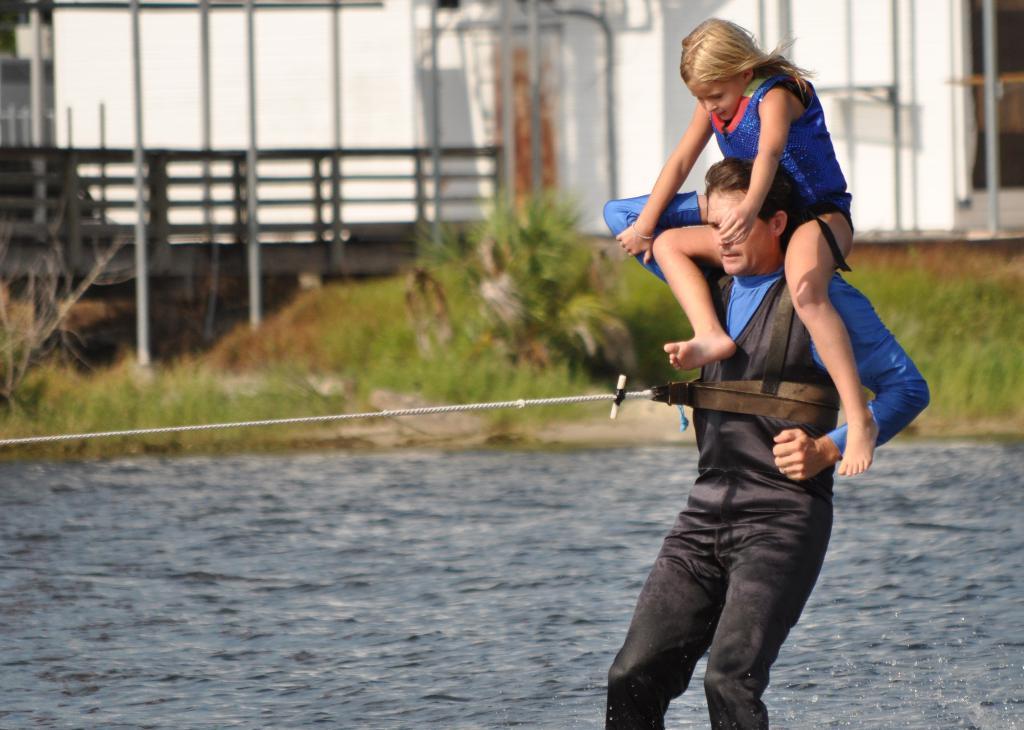Could you give a brief overview of what you see in this image? In this image, we can see a man standing, there is a girl sitting on the shoulders of man, we can see water. There is grass on the ground, we can see the fence. 